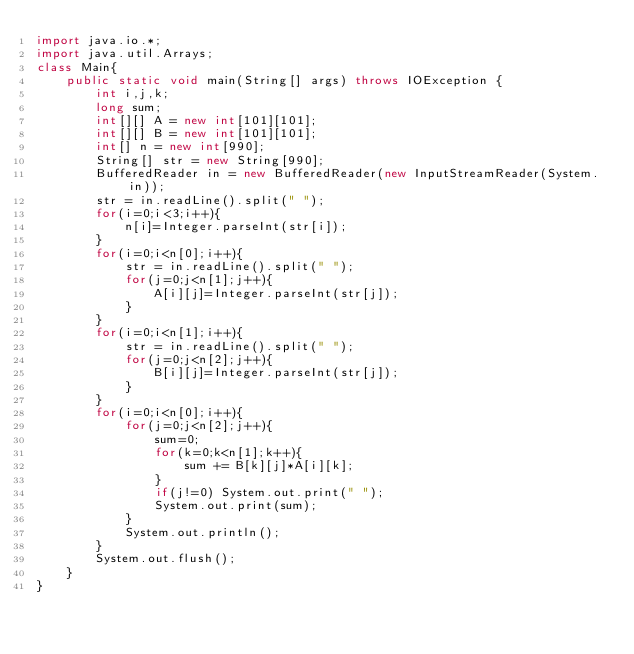<code> <loc_0><loc_0><loc_500><loc_500><_Java_>import java.io.*;
import java.util.Arrays;
class Main{
    public static void main(String[] args) throws IOException {
        int i,j,k;
        long sum;
        int[][] A = new int[101][101];
        int[][] B = new int[101][101];
        int[] n = new int[990];
        String[] str = new String[990];
        BufferedReader in = new BufferedReader(new InputStreamReader(System.in));
        str = in.readLine().split(" ");
        for(i=0;i<3;i++){
            n[i]=Integer.parseInt(str[i]);   
        }
        for(i=0;i<n[0];i++){
            str = in.readLine().split(" ");
            for(j=0;j<n[1];j++){
                A[i][j]=Integer.parseInt(str[j]);
            }
        }
        for(i=0;i<n[1];i++){
            str = in.readLine().split(" ");
            for(j=0;j<n[2];j++){
                B[i][j]=Integer.parseInt(str[j]);
            }
        }
        for(i=0;i<n[0];i++){
            for(j=0;j<n[2];j++){
                sum=0;
                for(k=0;k<n[1];k++){
                    sum += B[k][j]*A[i][k];             
                }
                if(j!=0) System.out.print(" ");
                System.out.print(sum);
            }
            System.out.println();
        }      
        System.out.flush();
    }
}</code> 